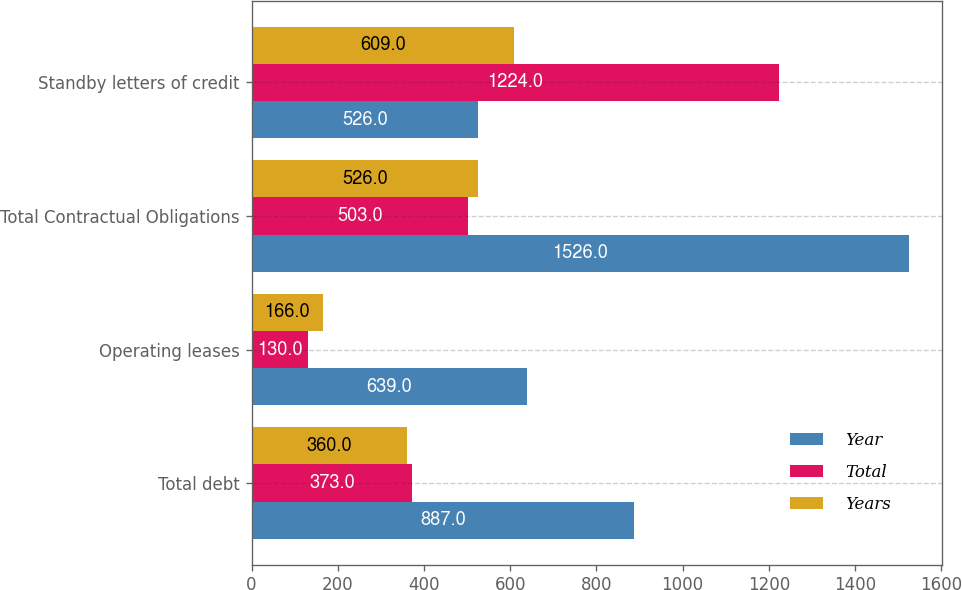Convert chart to OTSL. <chart><loc_0><loc_0><loc_500><loc_500><stacked_bar_chart><ecel><fcel>Total debt<fcel>Operating leases<fcel>Total Contractual Obligations<fcel>Standby letters of credit<nl><fcel>Year<fcel>887<fcel>639<fcel>1526<fcel>526<nl><fcel>Total<fcel>373<fcel>130<fcel>503<fcel>1224<nl><fcel>Years<fcel>360<fcel>166<fcel>526<fcel>609<nl></chart> 